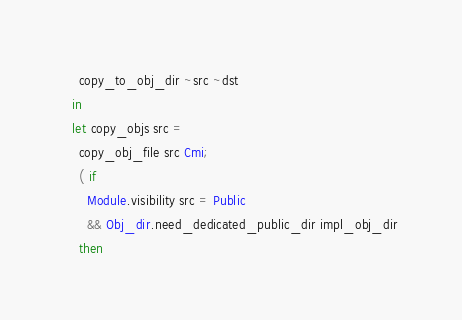Convert code to text. <code><loc_0><loc_0><loc_500><loc_500><_OCaml_>    copy_to_obj_dir ~src ~dst
  in
  let copy_objs src =
    copy_obj_file src Cmi;
    ( if
      Module.visibility src = Public
      && Obj_dir.need_dedicated_public_dir impl_obj_dir
    then</code> 